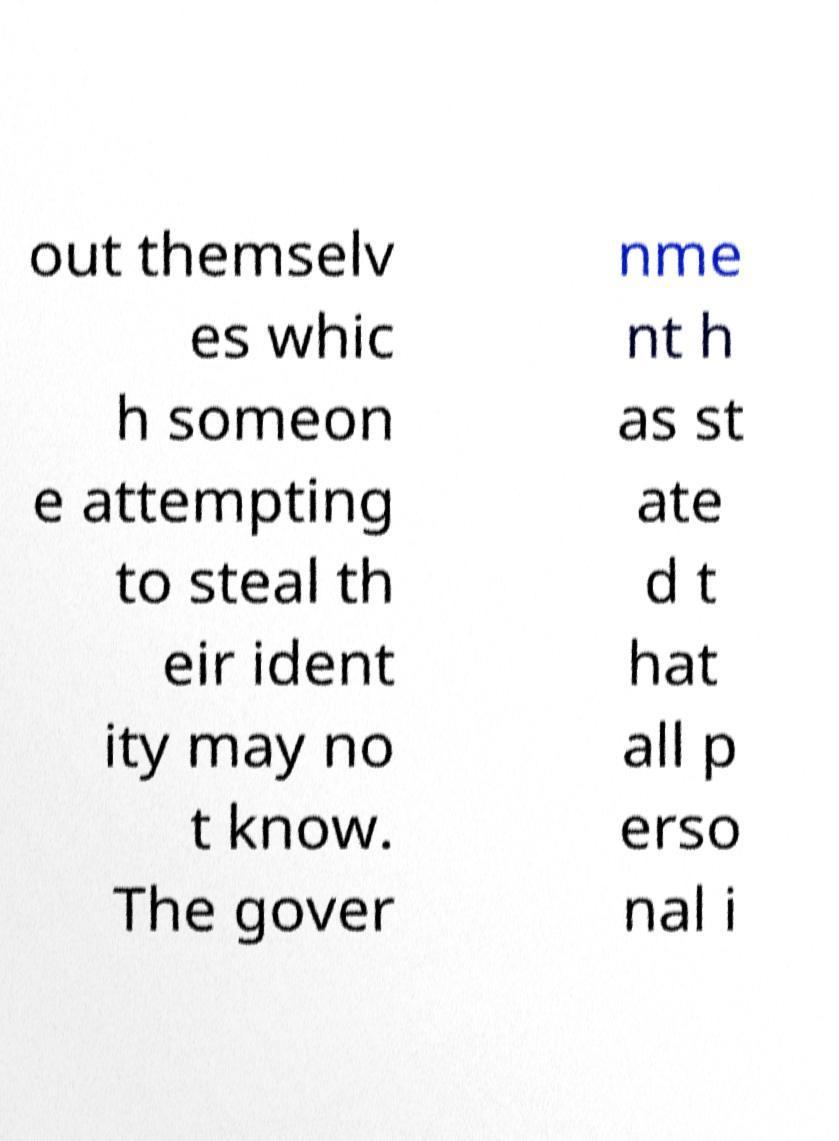Could you explain the context or the possible content missing from this image's visible text? Based on the visible text in the image, it seems to be discussing identity protection and some sort of statement by the government regarding personal information. The missing parts might detail specific measures or recommendations about safeguarding personal data or policies that have been enacted. 